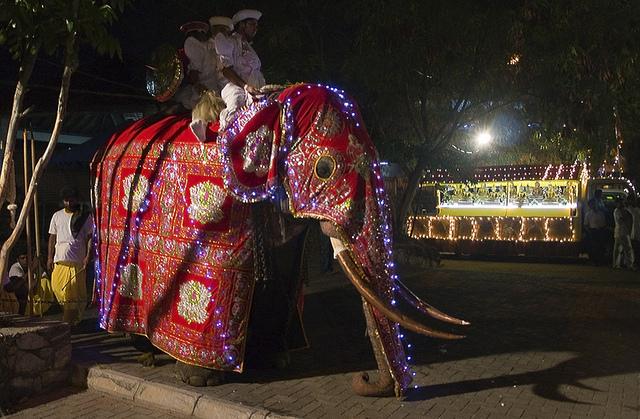What colors are on the elephant?
Write a very short answer. Red gold and purple. Is the elephant real?
Short answer required. Yes. How many elephants are in the photo?
Write a very short answer. 1. How is the elephant decorated?
Concise answer only. Colorfully draped. 